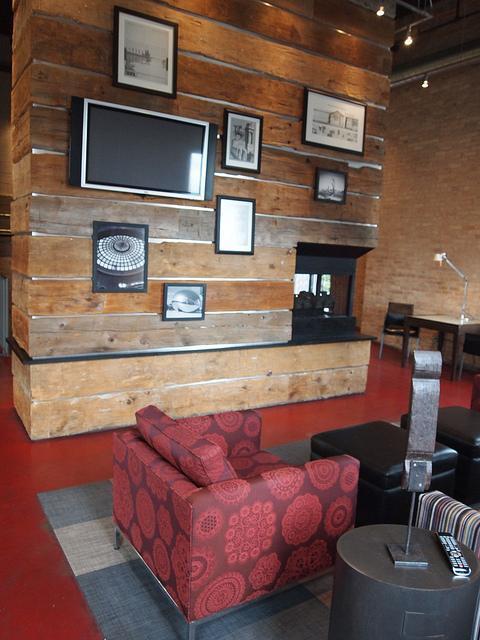How many couches can you see?
Give a very brief answer. 2. How many men are wearing blue caps?
Give a very brief answer. 0. 